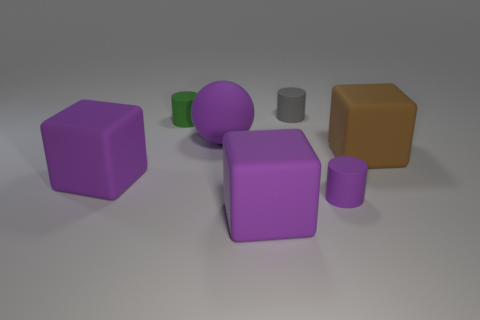Add 2 brown cubes. How many objects exist? 9 Subtract all cylinders. How many objects are left? 4 Add 1 small green cylinders. How many small green cylinders are left? 2 Add 7 purple rubber spheres. How many purple rubber spheres exist? 8 Subtract 1 purple cubes. How many objects are left? 6 Subtract all small gray matte cylinders. Subtract all green rubber cylinders. How many objects are left? 5 